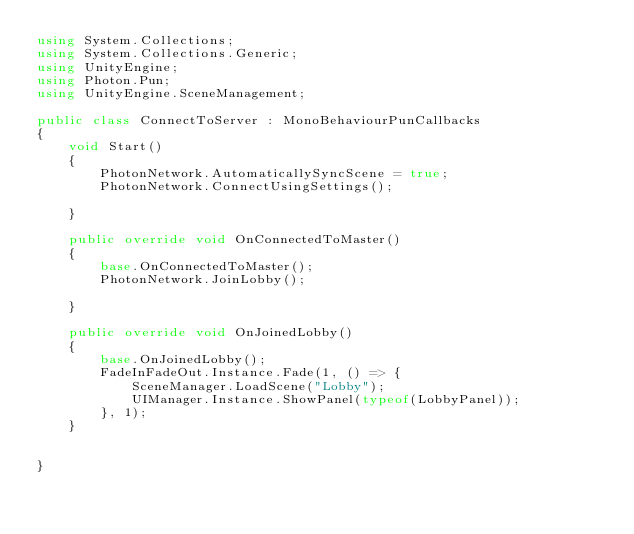<code> <loc_0><loc_0><loc_500><loc_500><_C#_>using System.Collections;
using System.Collections.Generic;
using UnityEngine;
using Photon.Pun;
using UnityEngine.SceneManagement;

public class ConnectToServer : MonoBehaviourPunCallbacks
{
    void Start()
    {
        PhotonNetwork.AutomaticallySyncScene = true;
        PhotonNetwork.ConnectUsingSettings();
        
    }

    public override void OnConnectedToMaster()
    {
        base.OnConnectedToMaster();
        PhotonNetwork.JoinLobby();

    }

    public override void OnJoinedLobby()
    {
        base.OnJoinedLobby();
        FadeInFadeOut.Instance.Fade(1, () => {
            SceneManager.LoadScene("Lobby");
            UIManager.Instance.ShowPanel(typeof(LobbyPanel));
        }, 1);
    }


}
</code> 